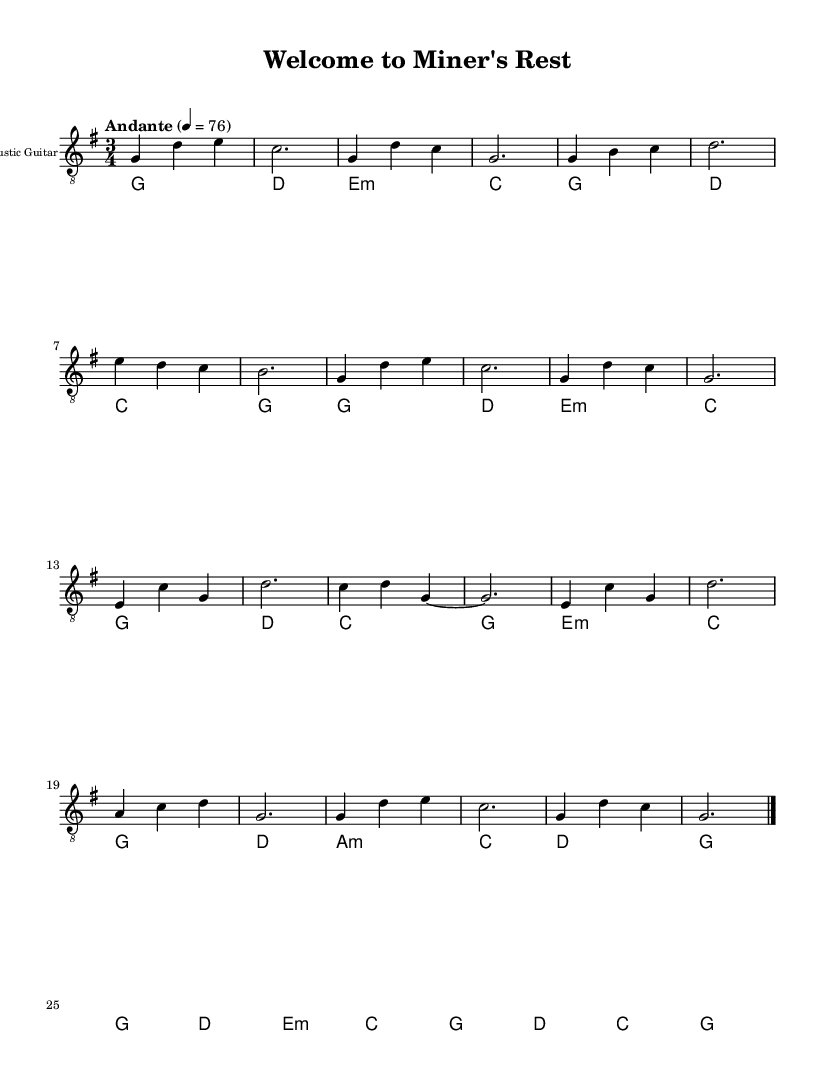What is the key signature of this music? The key signature is G major, which has one sharp (F#). This can be identified by looking at the key signature symbol at the beginning of the staff.
Answer: G major What is the time signature of this music? The time signature is 3/4, indicated by the numbers at the start of the sheet music. The top number (3) signifies three beats per measure, and the bottom number (4) indicates that a quarter note gets one beat.
Answer: 3/4 What is the tempo marking for this music? The tempo marking is "Andante," which suggests a moderately slow pace. This is indicated in the tempo text written above the score.
Answer: Andante How many measures are in the chorus section of this music? The chorus has four measures, which can be determined by counting the bar lines in the section labeled as the chorus. Each measure contains notes grouped between vertical lines.
Answer: 4 What chord follows the A minor chord in the rhythmic guitar part? The chord following the A minor chord is C major. This can be seen by looking at the chords written above the first part and identifying the sequence.
Answer: C Which section of the music features a bridge? The section labeled as "Bridge" includes its own distinct measures, indicated by the text "Bridge" above the music staff. This is a typical structural element often included in ballads.
Answer: Bridge What is the final chord at the end of the outro? The final chord in the outro is G major, which is identified at the end of the measure before the double bar line, showing its resolution at the conclusion of the piece.
Answer: G major 